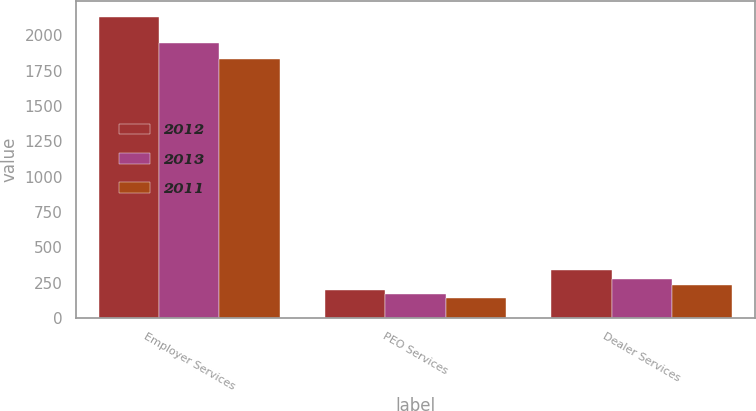Convert chart to OTSL. <chart><loc_0><loc_0><loc_500><loc_500><stacked_bar_chart><ecel><fcel>Employer Services<fcel>PEO Services<fcel>Dealer Services<nl><fcel>2012<fcel>2134.2<fcel>199.2<fcel>335.7<nl><fcel>2013<fcel>1949.2<fcel>170.6<fcel>277.6<nl><fcel>2011<fcel>1831.9<fcel>137.3<fcel>231.3<nl></chart> 